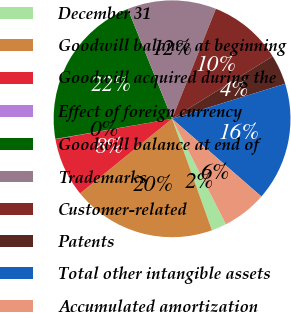Convert chart. <chart><loc_0><loc_0><loc_500><loc_500><pie_chart><fcel>December 31<fcel>Goodwill balance at beginning<fcel>Goodwill acquired during the<fcel>Effect of foreign currency<fcel>Goodwill balance at end of<fcel>Trademarks<fcel>Customer-related<fcel>Patents<fcel>Total other intangible assets<fcel>Accumulated amortization<nl><fcel>2.05%<fcel>19.61%<fcel>8.1%<fcel>0.04%<fcel>21.62%<fcel>12.13%<fcel>10.12%<fcel>4.07%<fcel>16.17%<fcel>6.09%<nl></chart> 